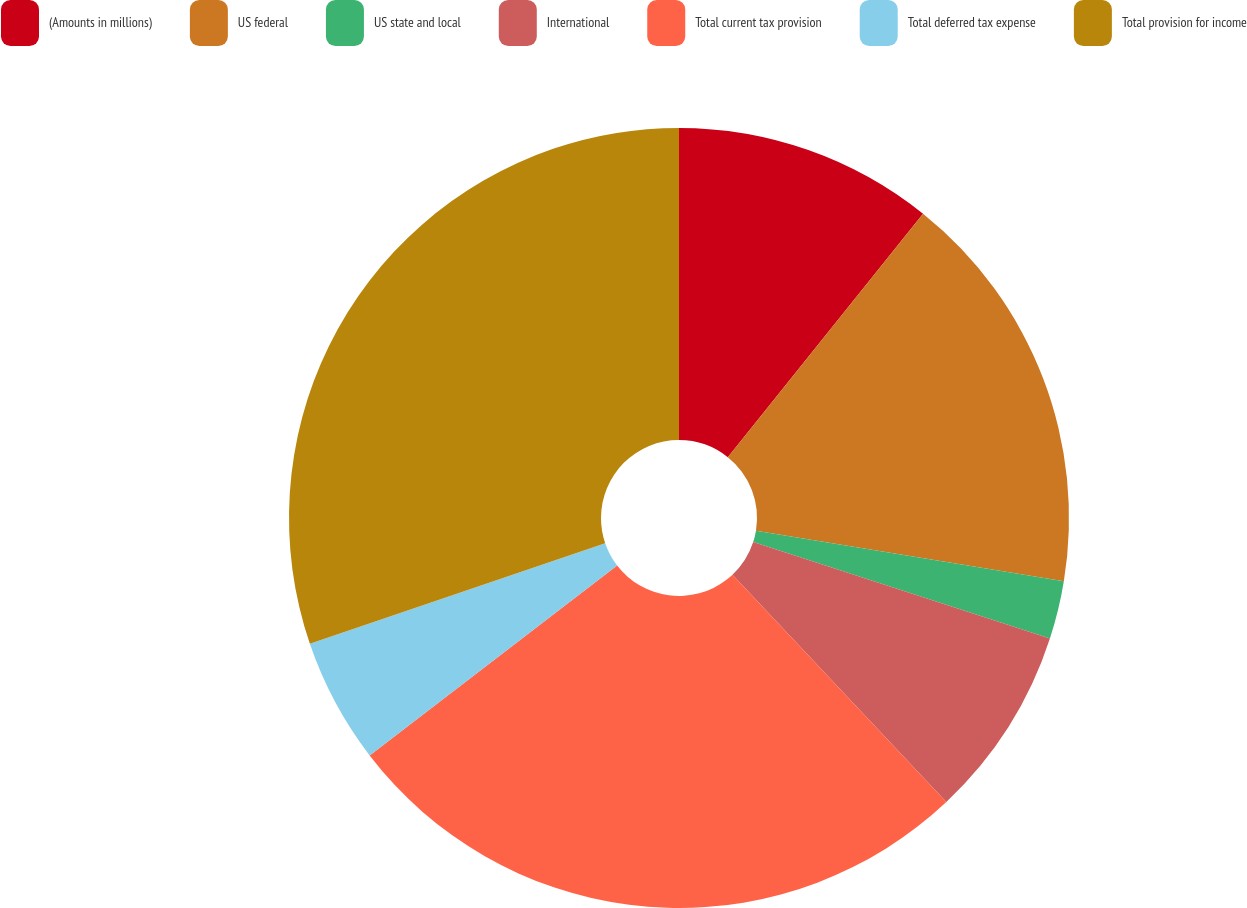Convert chart to OTSL. <chart><loc_0><loc_0><loc_500><loc_500><pie_chart><fcel>(Amounts in millions)<fcel>US federal<fcel>US state and local<fcel>International<fcel>Total current tax provision<fcel>Total deferred tax expense<fcel>Total provision for income<nl><fcel>10.76%<fcel>16.83%<fcel>2.41%<fcel>7.98%<fcel>26.6%<fcel>5.19%<fcel>30.23%<nl></chart> 